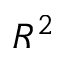<formula> <loc_0><loc_0><loc_500><loc_500>R ^ { 2 }</formula> 